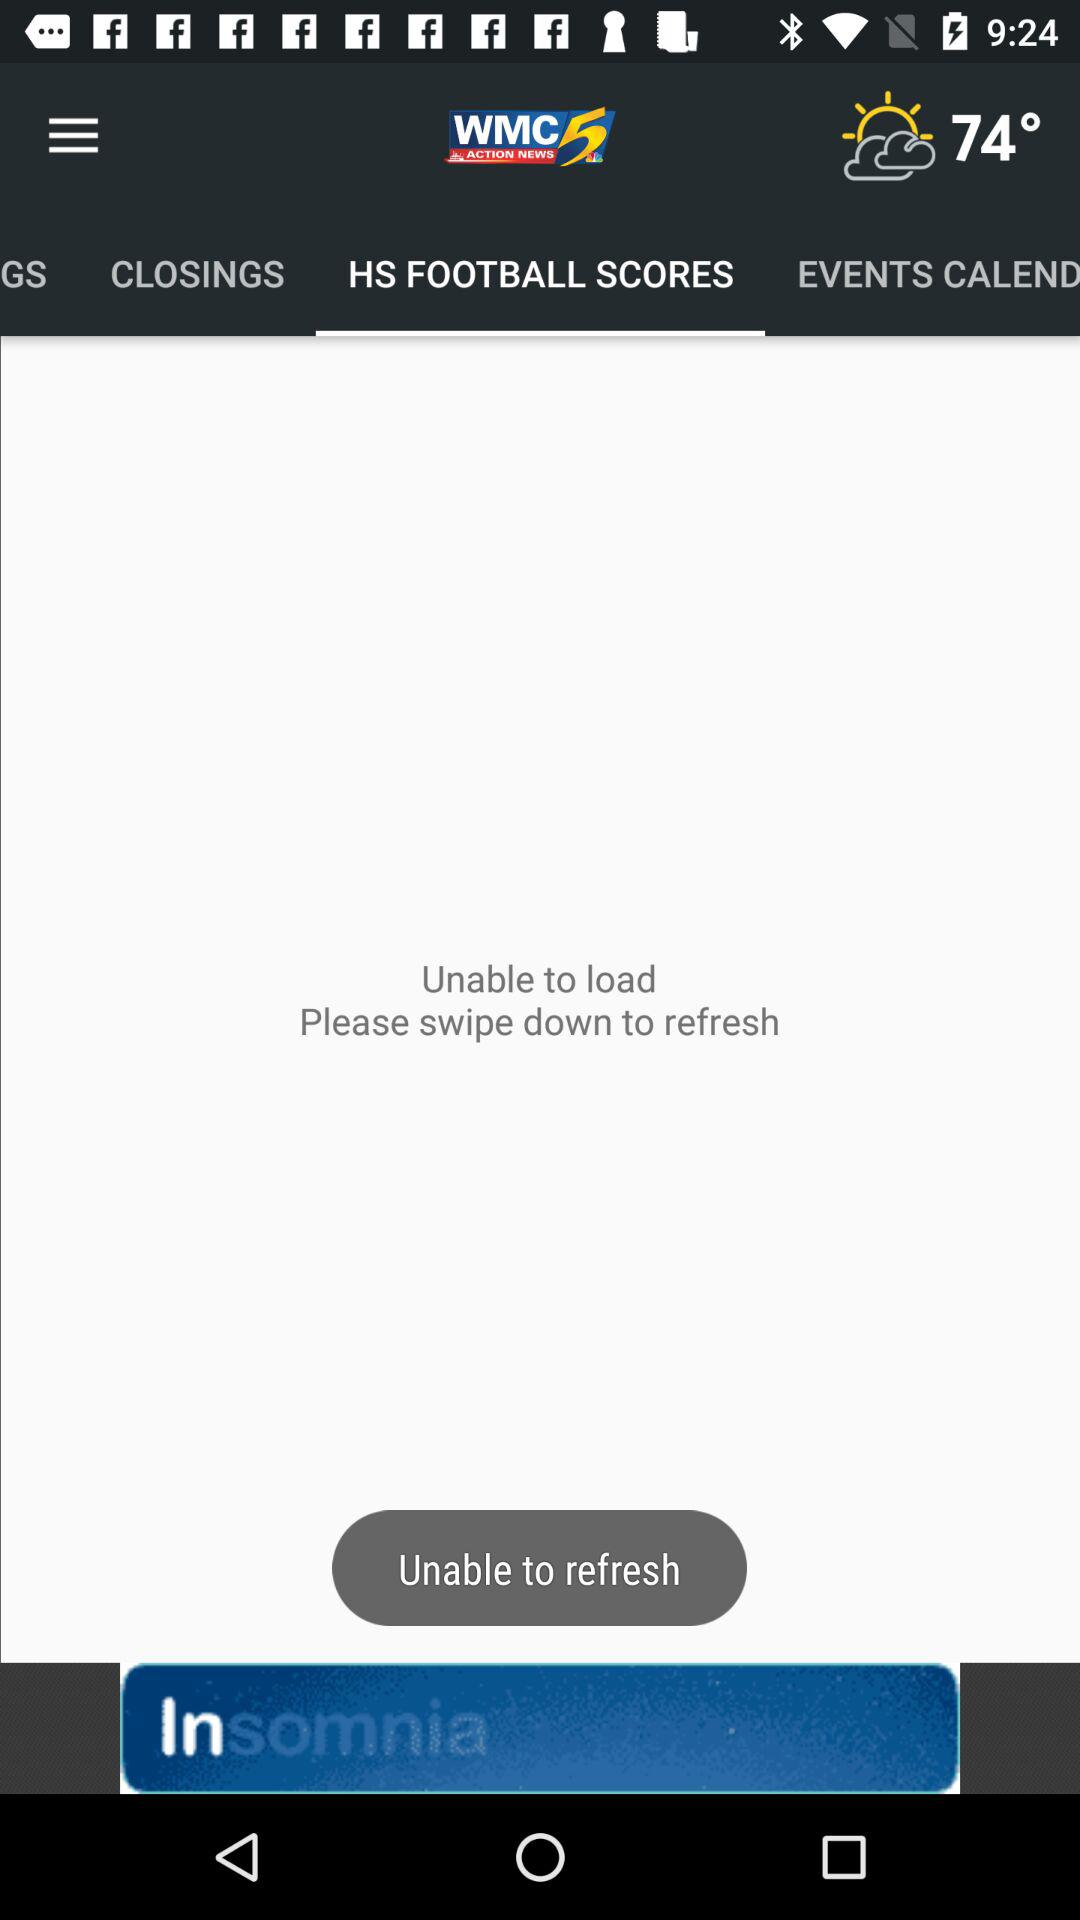What is the temperature shown on the screen? The temperature is 74°. 